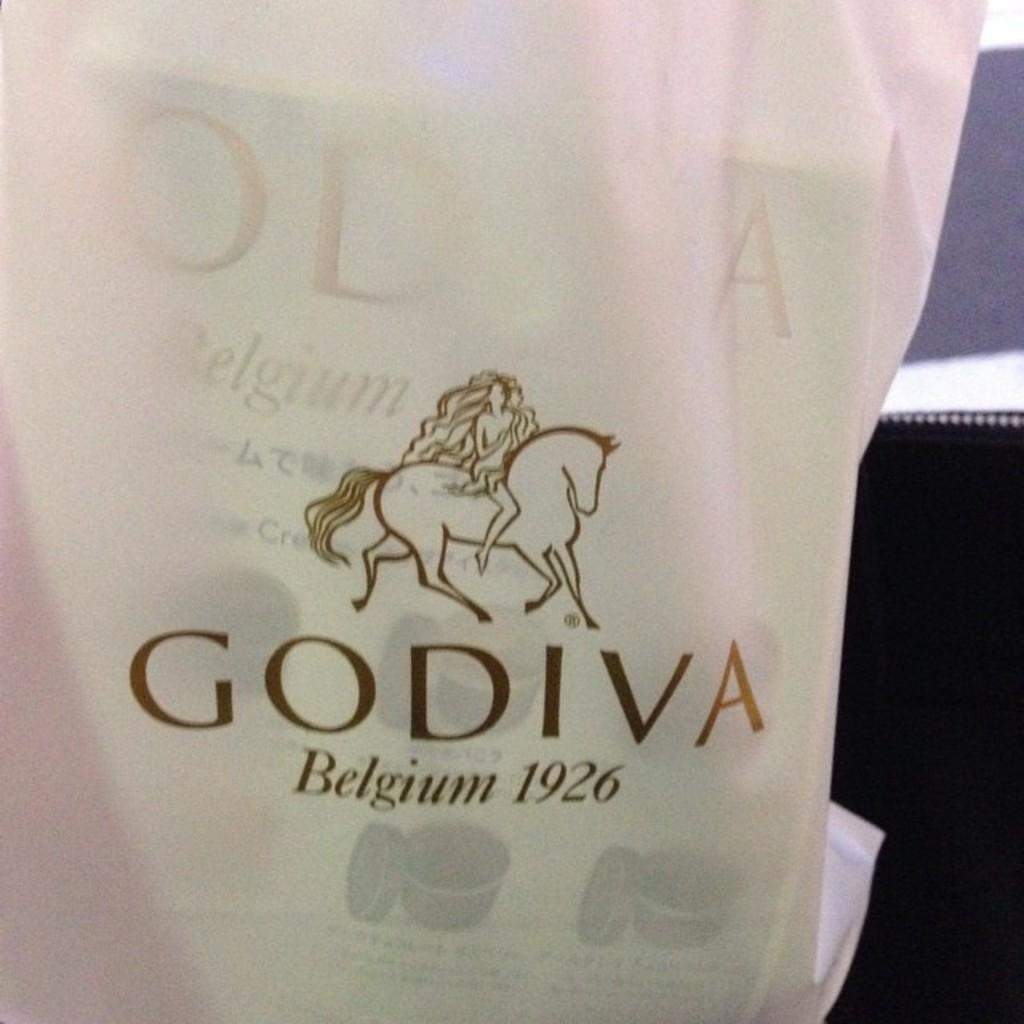<image>
Present a compact description of the photo's key features. Bag for a wine that says Godiva Belgium 1926. 